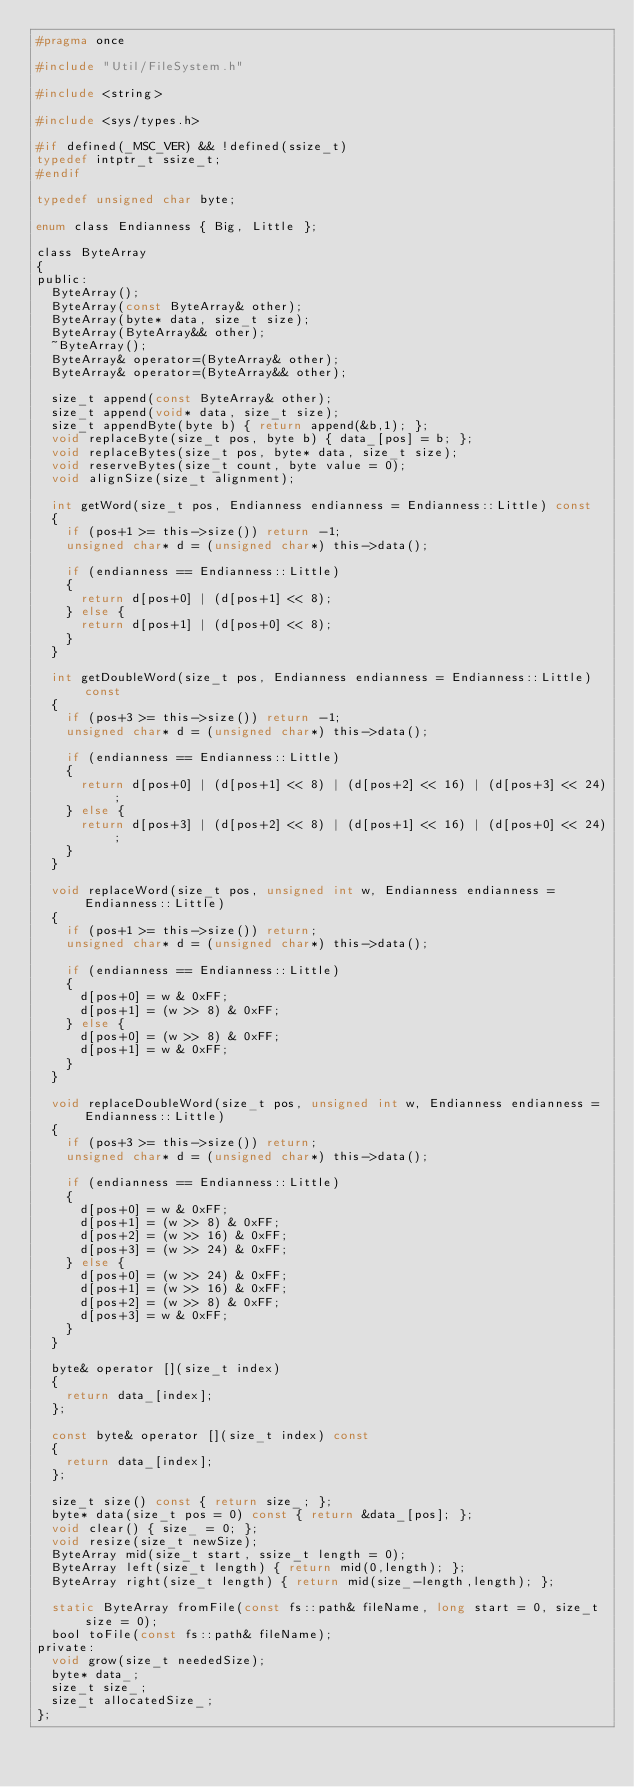<code> <loc_0><loc_0><loc_500><loc_500><_C_>#pragma once

#include "Util/FileSystem.h"

#include <string>

#include <sys/types.h>

#if defined(_MSC_VER) && !defined(ssize_t)
typedef intptr_t ssize_t;
#endif

typedef unsigned char byte;

enum class Endianness { Big, Little };

class ByteArray
{
public:
	ByteArray();
	ByteArray(const ByteArray& other);
	ByteArray(byte* data, size_t size);
	ByteArray(ByteArray&& other);
	~ByteArray();
	ByteArray& operator=(ByteArray& other);
	ByteArray& operator=(ByteArray&& other);

	size_t append(const ByteArray& other);
	size_t append(void* data, size_t size);
	size_t appendByte(byte b) { return append(&b,1); };
	void replaceByte(size_t pos, byte b) { data_[pos] = b; };
	void replaceBytes(size_t pos, byte* data, size_t size);
	void reserveBytes(size_t count, byte value = 0);
	void alignSize(size_t alignment);

	int getWord(size_t pos, Endianness endianness = Endianness::Little) const
	{
		if (pos+1 >= this->size()) return -1;
		unsigned char* d = (unsigned char*) this->data();

		if (endianness == Endianness::Little)
		{
			return d[pos+0] | (d[pos+1] << 8);
		} else {
			return d[pos+1] | (d[pos+0] << 8);
		}
	}

	int getDoubleWord(size_t pos, Endianness endianness = Endianness::Little) const
	{
		if (pos+3 >= this->size()) return -1;
		unsigned char* d = (unsigned char*) this->data();

		if (endianness == Endianness::Little)
		{
			return d[pos+0] | (d[pos+1] << 8) | (d[pos+2] << 16) | (d[pos+3] << 24);
		} else {
			return d[pos+3] | (d[pos+2] << 8) | (d[pos+1] << 16) | (d[pos+0] << 24);
		}
	}
	
	void replaceWord(size_t pos, unsigned int w, Endianness endianness = Endianness::Little)
	{
		if (pos+1 >= this->size()) return;
		unsigned char* d = (unsigned char*) this->data();

		if (endianness == Endianness::Little)
		{
			d[pos+0] = w & 0xFF;
			d[pos+1] = (w >> 8) & 0xFF;
		} else {
			d[pos+0] = (w >> 8) & 0xFF;
			d[pos+1] = w & 0xFF;
		}
	}

	void replaceDoubleWord(size_t pos, unsigned int w, Endianness endianness = Endianness::Little)
	{
		if (pos+3 >= this->size()) return;
		unsigned char* d = (unsigned char*) this->data();
		
		if (endianness == Endianness::Little)
		{
			d[pos+0] = w & 0xFF;
			d[pos+1] = (w >> 8) & 0xFF;
			d[pos+2] = (w >> 16) & 0xFF;
			d[pos+3] = (w >> 24) & 0xFF;
		} else {
			d[pos+0] = (w >> 24) & 0xFF;
			d[pos+1] = (w >> 16) & 0xFF;
			d[pos+2] = (w >> 8) & 0xFF;
			d[pos+3] = w & 0xFF;
		}
	}

	byte& operator [](size_t index)
	{
		return data_[index];
	};
	
	const byte& operator [](size_t index) const
	{
		return data_[index];
	};

	size_t size() const { return size_; };
	byte* data(size_t pos = 0) const { return &data_[pos]; };
	void clear() { size_ = 0; };
	void resize(size_t newSize);
	ByteArray mid(size_t start, ssize_t length = 0);
	ByteArray left(size_t length) { return mid(0,length); };
	ByteArray right(size_t length) { return mid(size_-length,length); };

	static ByteArray fromFile(const fs::path& fileName, long start = 0, size_t size = 0);
	bool toFile(const fs::path& fileName);
private:
	void grow(size_t neededSize);
	byte* data_;
	size_t size_;
	size_t allocatedSize_;
};
</code> 